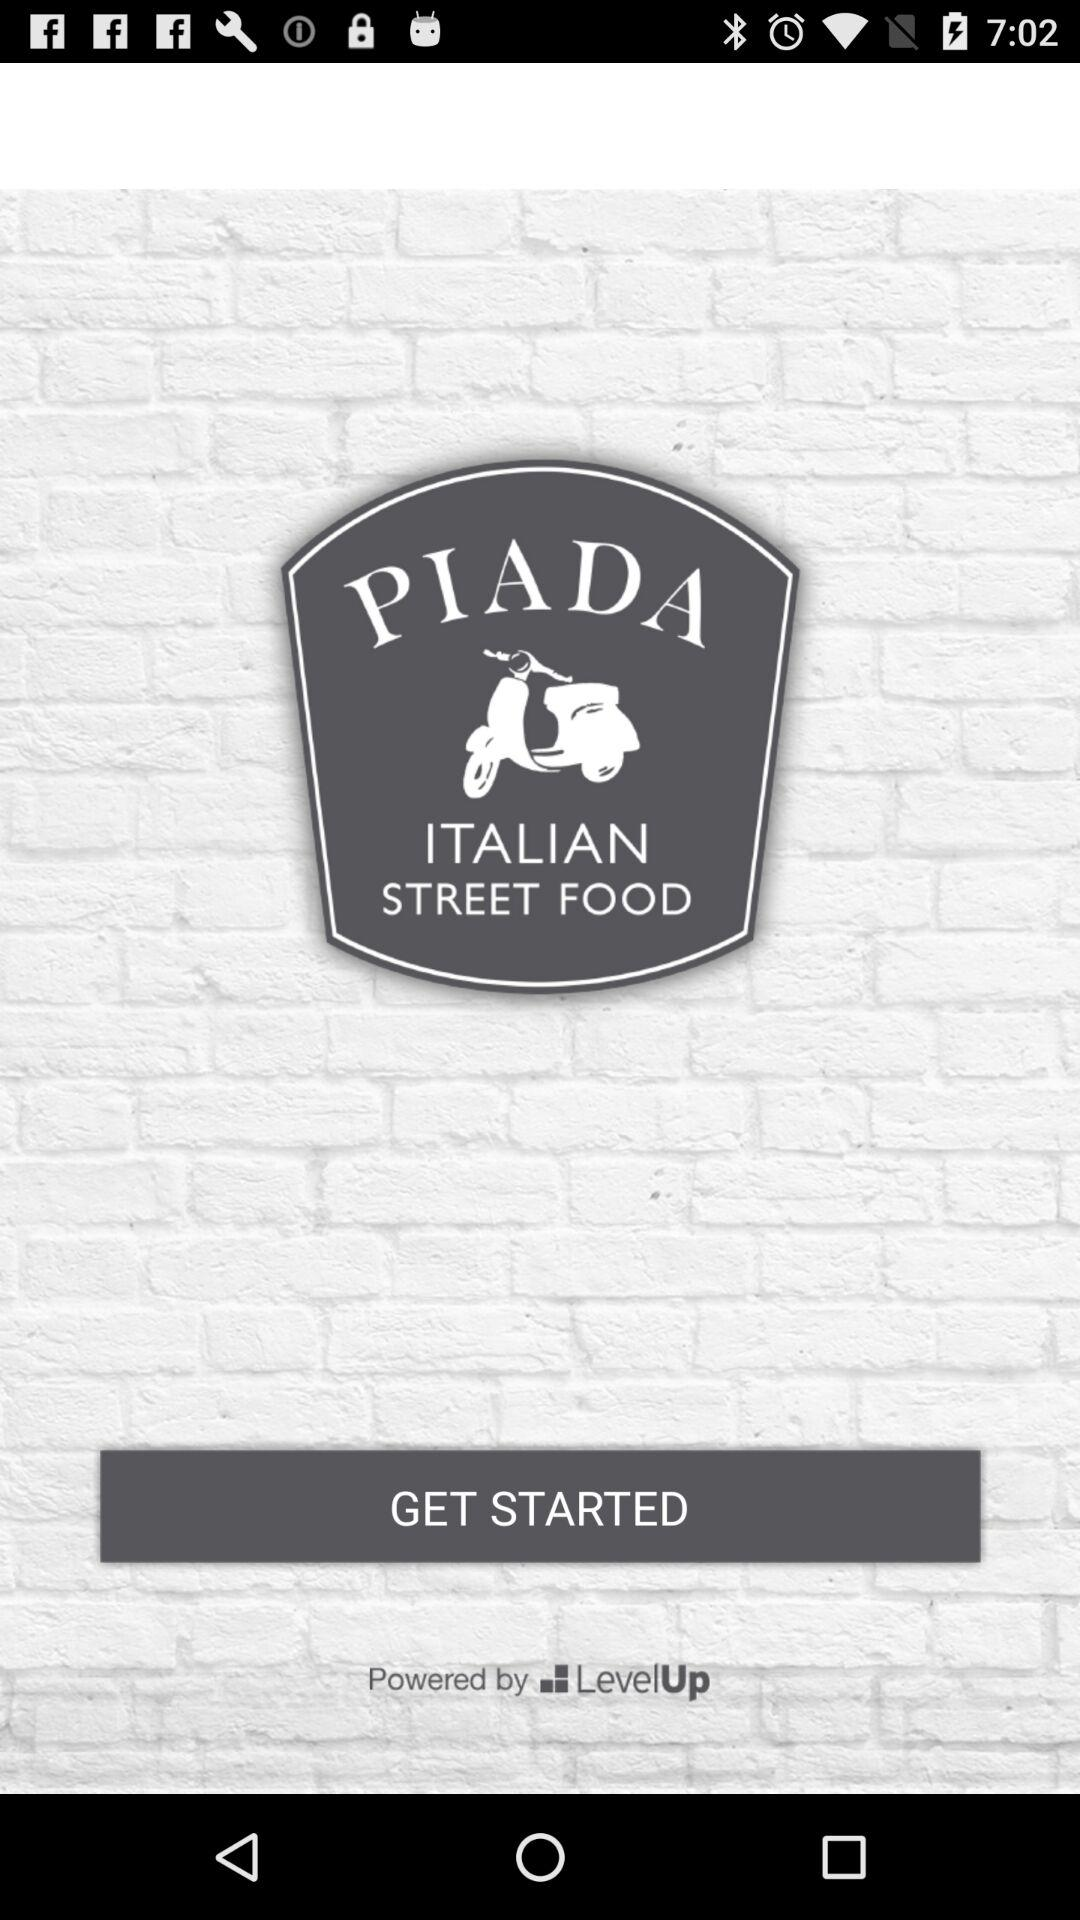What type of street food does "PIADA" serve? "PIADA" serves Italian street food. 